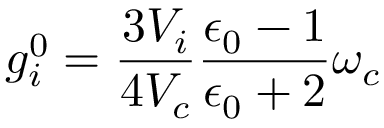<formula> <loc_0><loc_0><loc_500><loc_500>g _ { i } ^ { 0 } = \frac { 3 V _ { i } } { 4 V _ { c } } \frac { \epsilon _ { 0 } - 1 } { \epsilon _ { 0 } + 2 } \omega _ { c }</formula> 